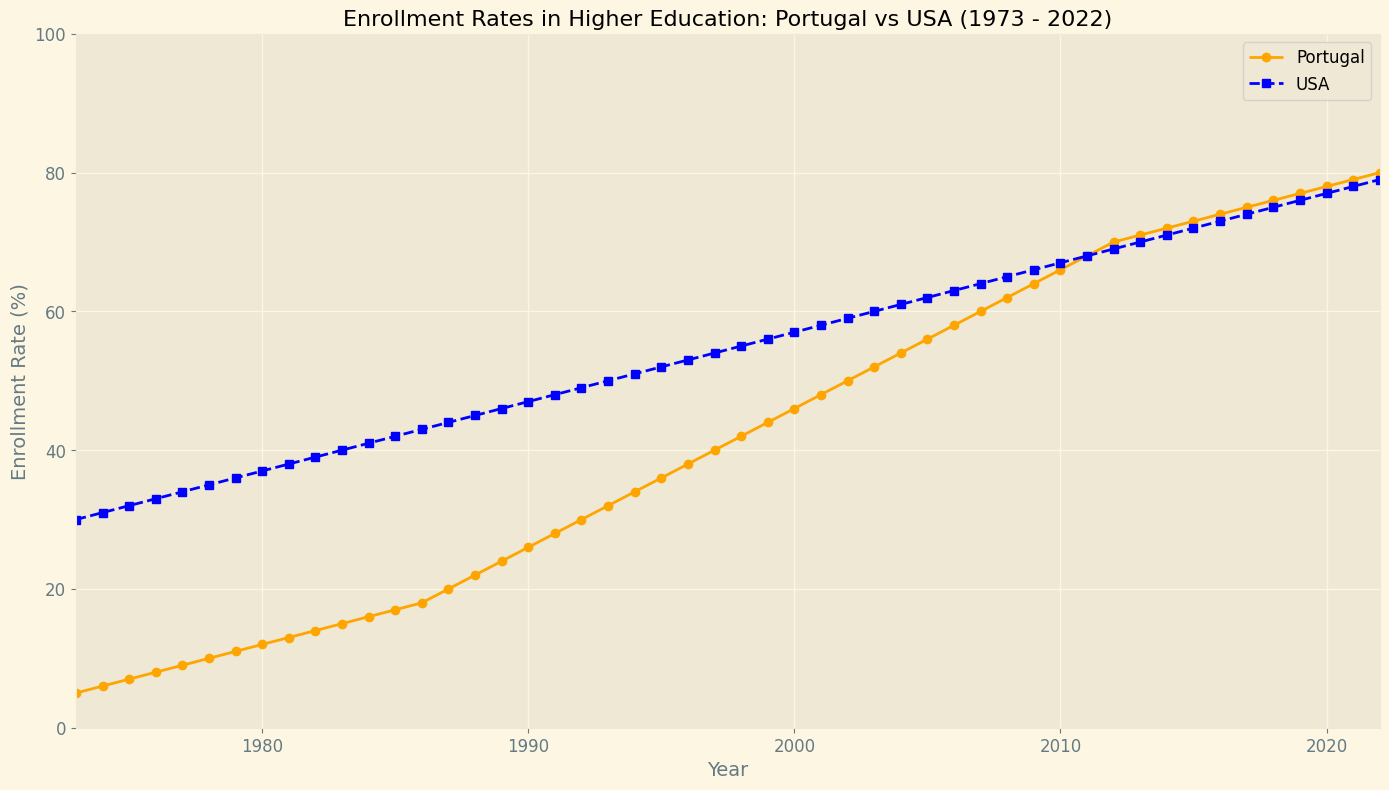Which country had a higher enrollment rate in 1985? Look at the values on the y-axis for the year 1985 for both Portugal and the USA. Portugal had an enrollment rate of 17%, and the USA had 42%.
Answer: USA What was the enrollment rate in Portugal in 1992? Refer to the point on the Portugal line for the year 1992. The y-axis value for Portugal in 1992 is 30%.
Answer: 30% By how much did the enrollment rate in the USA exceed that in Portugal in 2000? For the year 2000, the enrollment rate for the USA is 57% and for Portugal is 46%. Subtract Portugal's rate from the USA's rate. 57% - 46% = 11%
Answer: 11% In which year did Portugal first surpass an enrollment rate of 40%? Find the first point on the Portugal line where the y-axis value exceeds 40%. This occurs in the year 1997.
Answer: 1997 How did the enrollment rates in both countries change between 2017 and 2018? For 2017, enrollment rates are 75% (Portugal) and 74% (USA). For 2018, they are 76% (Portugal) and 75% (USA). Compute the changes: Portugal 76% - 75% = 1%; USA 75% - 74% = 1%.
Answer: Both increased by 1% What is the overall trend of enrollment rates in Portugal over the 50 years? Examine the shape of the Portugal line from 1973 to 2022. The line generally trends upwards, indicating a consistent increase in enrollment rates over the period.
Answer: Increasing Did the enrollment rate in the USA ever decrease within the given 50 years? Analyze the USA line from 1973 to 2022. The line consistently trends upwards with no drops, indicating a never-decreasing enrollment rate.
Answer: No What were the enrollment rates in Portugal and the USA in 2011? Refer to the values at the year 2011 on both lines. Portugal's rate is 68%, and the USA's rate is 68%.
Answer: Both 68% In 2022, what is the difference in enrollment rates between the USA and Portugal? Look at the y-axis values for 2022 for both Portugal (80%) and the USA (79%). Find the difference: 80% - 79% = 1%.
Answer: 1% By how much did Portugal's enrollment rate increase from 1987 to 1988? For 1987, the enrollment rate in Portugal is 20%, and for 1988, it is 22%. Compute the difference: 22% - 20% = 2%.
Answer: 2% 